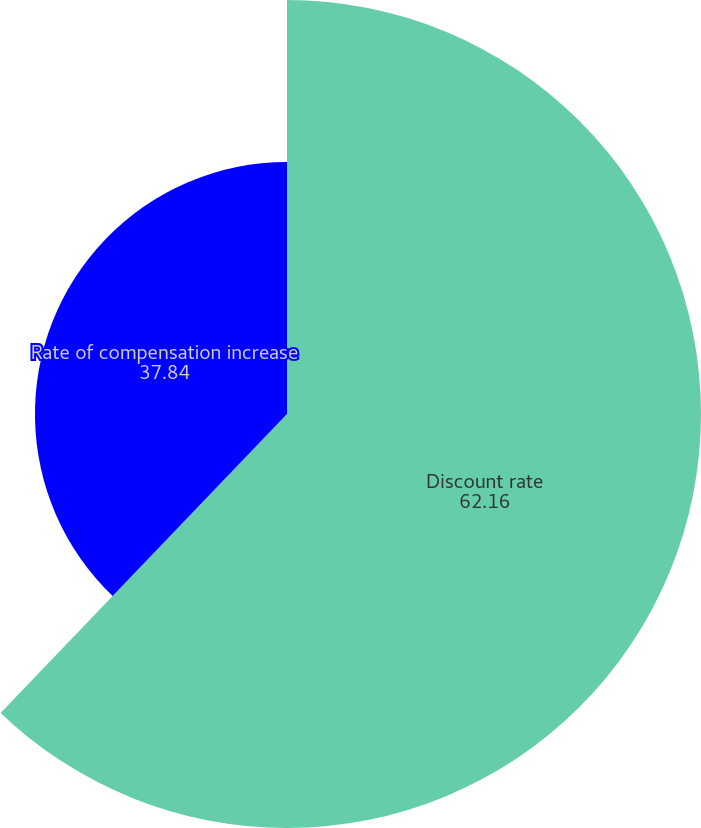Convert chart. <chart><loc_0><loc_0><loc_500><loc_500><pie_chart><fcel>Discount rate<fcel>Rate of compensation increase<nl><fcel>62.16%<fcel>37.84%<nl></chart> 